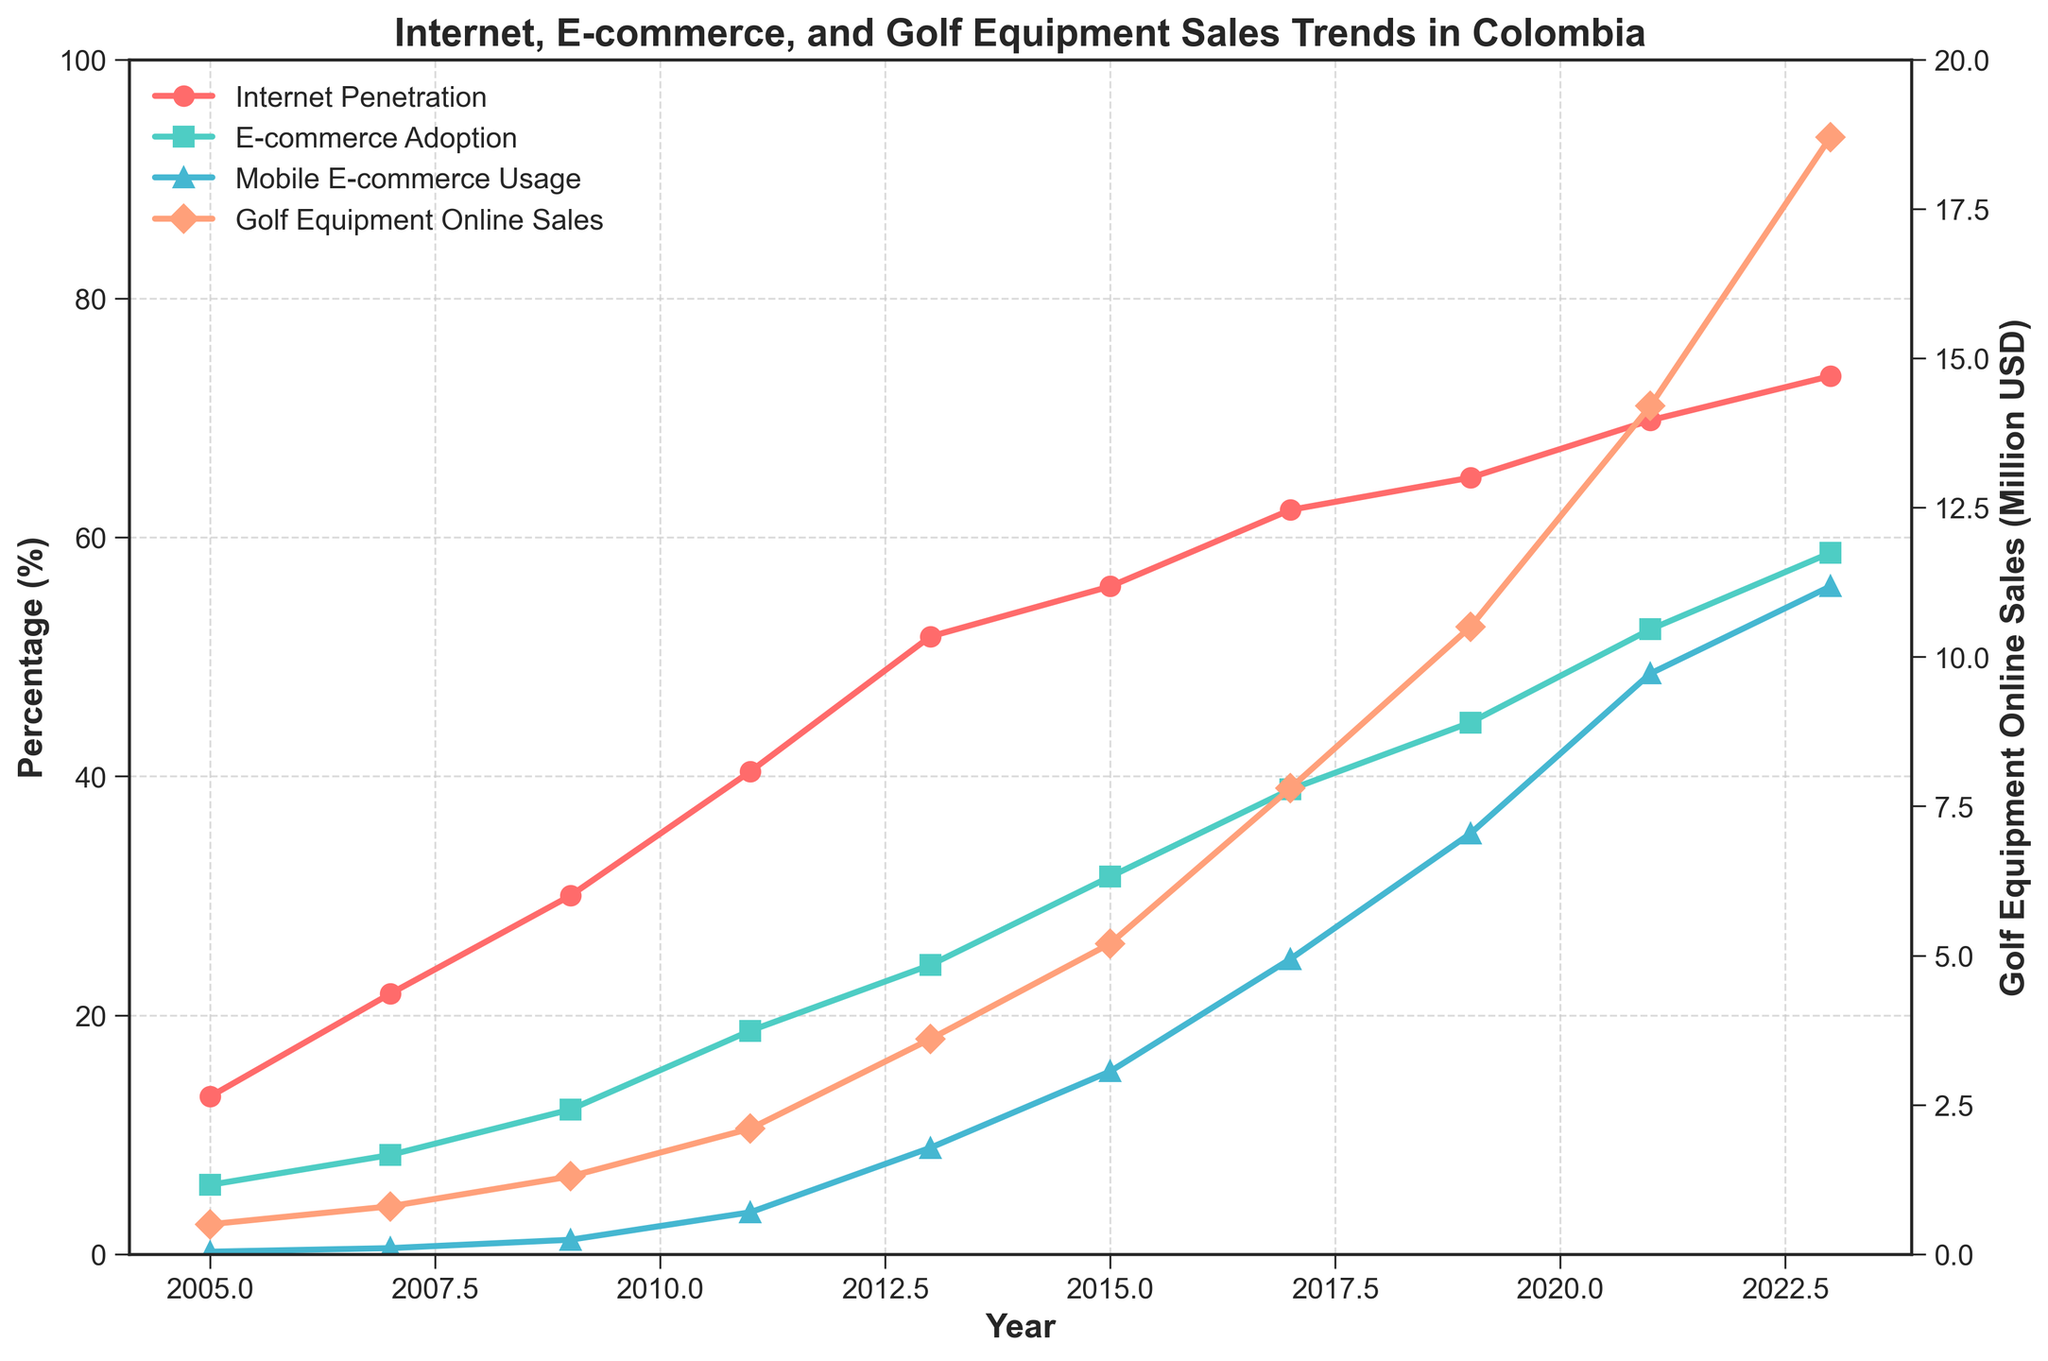What was the difference in Internet penetration between 2005 and 2023? To find the difference, subtract the Internet penetration in 2005 from that in 2023: 73.5% - 13.2% = 60.3%
Answer: 60.3% In what year did e-commerce adoption first exceed 50% of Internet users? Look at the line representing e-commerce adoption and find the year when it first surpasses 50%. This happens in 2021.
Answer: 2021 How did golf equipment online sales change from 2019 to 2023? Compare the values for golf equipment online sales in 2019 and 2023: 18.7 million USD in 2023 and 10.5 million USD in 2019, the difference is 18.7 - 10.5 = 8.2 million USD.
Answer: Increased by 8.2 million USD Which year saw the highest increase in mobile e-commerce usage compared to the previous year? To find the highest increase, calculate the year-to-year differences in mobile e-commerce usage: the highest difference is between 2019 and 2021 (48.6% - 35.2% = 13.4%).
Answer: Between 2019 and 2021 In which year did Internet penetration surpass 50% for the first time? Find the year where the Internet penetration line first crosses the 50% mark, which is in 2013.
Answer: 2013 What is the sales trend for golf equipment from 2011 to 2023? Observe the trend of the golf equipment sales line and note that it consistently increases from 2.1 million USD in 2011 to 18.7 million USD in 2023.
Answer: Consistently increasing By how much did mobile e-commerce usage grow from 2015 to 2019? Subtract the mobile e-commerce usage value in 2015 from that in 2019: 35.2% - 15.3% = 19.9%.
Answer: 19.9% Which color represents the Internet penetration line in the plot? Identify the color by visual inspection of the plot: the Internet penetration line is represented by a red color.
Answer: Red 